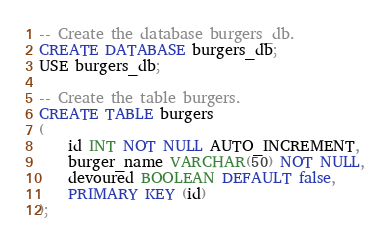Convert code to text. <code><loc_0><loc_0><loc_500><loc_500><_SQL_>-- Create the database burgers_db.
CREATE DATABASE burgers_db;
USE burgers_db;

-- Create the table burgers.
CREATE TABLE burgers
(
    id INT NOT NULL AUTO_INCREMENT,
    burger_name VARCHAR(50) NOT NULL,
    devoured BOOLEAN DEFAULT false,
    PRIMARY KEY (id)
);

</code> 